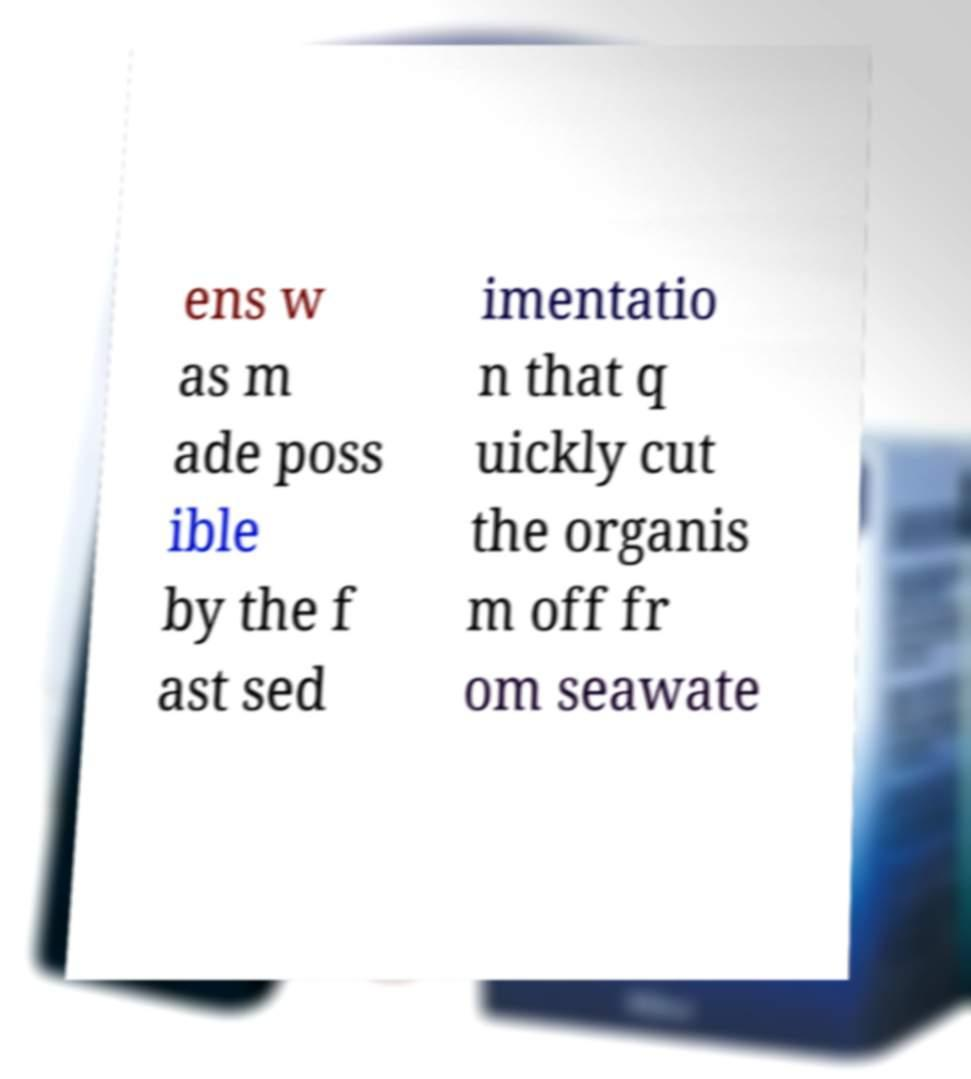There's text embedded in this image that I need extracted. Can you transcribe it verbatim? ens w as m ade poss ible by the f ast sed imentatio n that q uickly cut the organis m off fr om seawate 